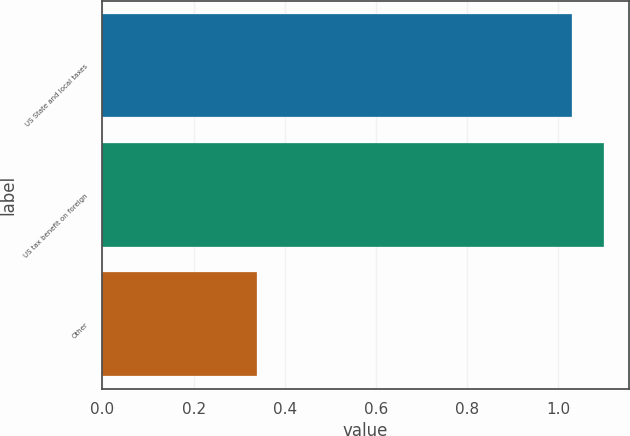Convert chart to OTSL. <chart><loc_0><loc_0><loc_500><loc_500><bar_chart><fcel>US State and local taxes<fcel>US tax benefit on foreign<fcel>Other<nl><fcel>1.03<fcel>1.1<fcel>0.34<nl></chart> 